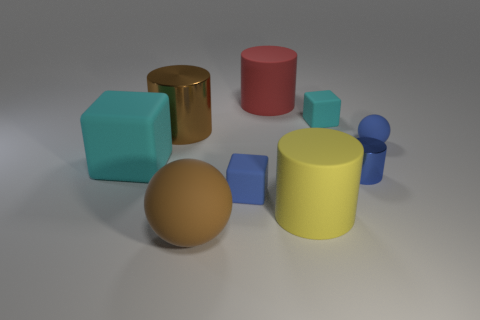Subtract all green cylinders. Subtract all purple blocks. How many cylinders are left? 4 Add 1 big yellow cylinders. How many objects exist? 10 Subtract all blocks. How many objects are left? 6 Add 3 cylinders. How many cylinders are left? 7 Add 9 brown matte spheres. How many brown matte spheres exist? 10 Subtract 0 gray cubes. How many objects are left? 9 Subtract all tiny blue cylinders. Subtract all yellow objects. How many objects are left? 7 